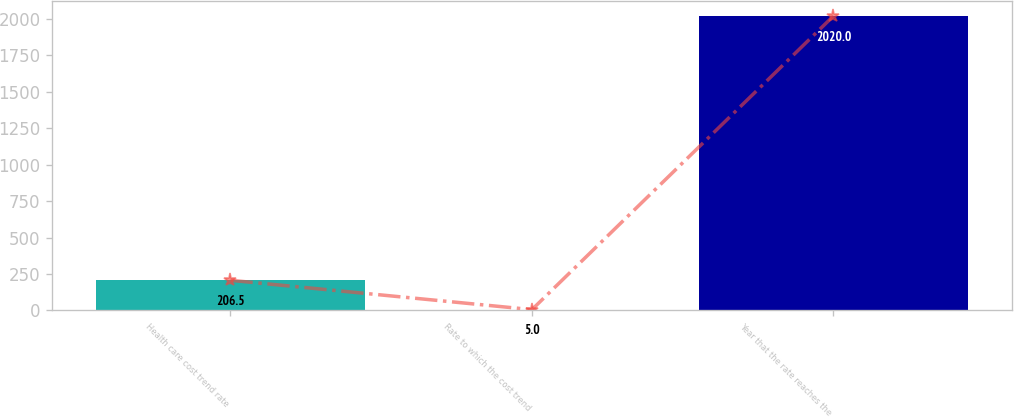Convert chart. <chart><loc_0><loc_0><loc_500><loc_500><bar_chart><fcel>Health care cost trend rate<fcel>Rate to which the cost trend<fcel>Year that the rate reaches the<nl><fcel>206.5<fcel>5<fcel>2020<nl></chart> 